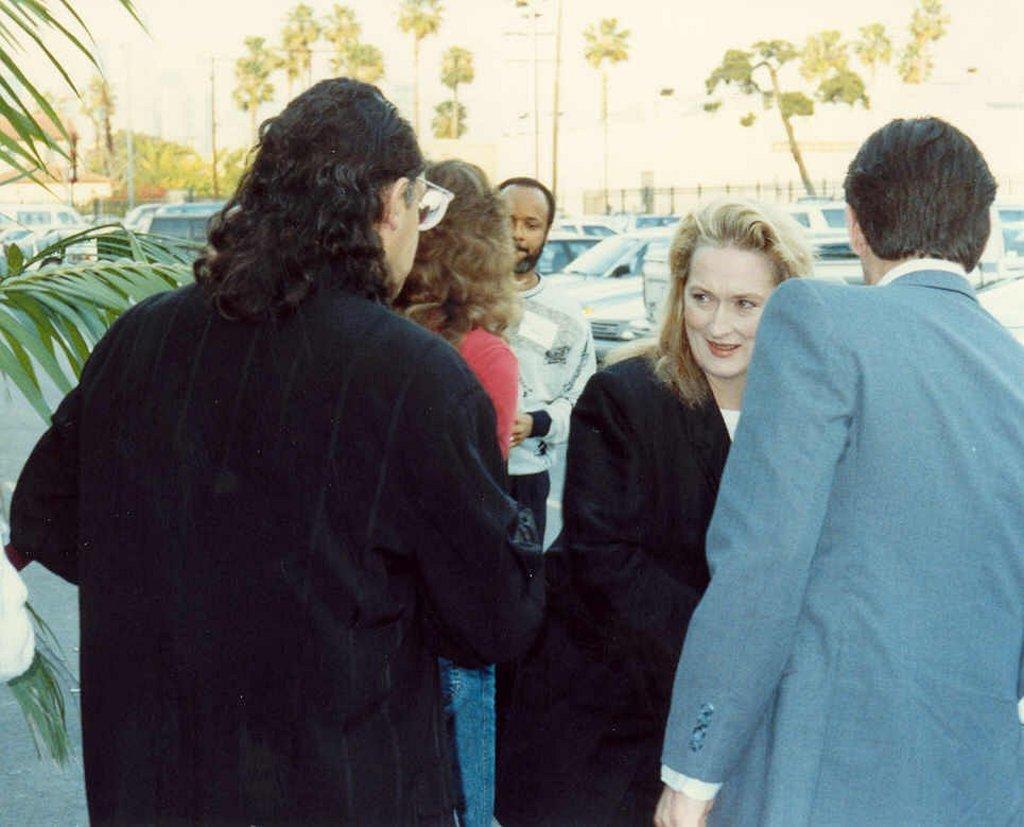Describe this image in one or two sentences. In this picture we can see five people standing and a woman smiling and at the back of them we can see vehicles, trees, fence and some objects and in the background we can see the sky. 